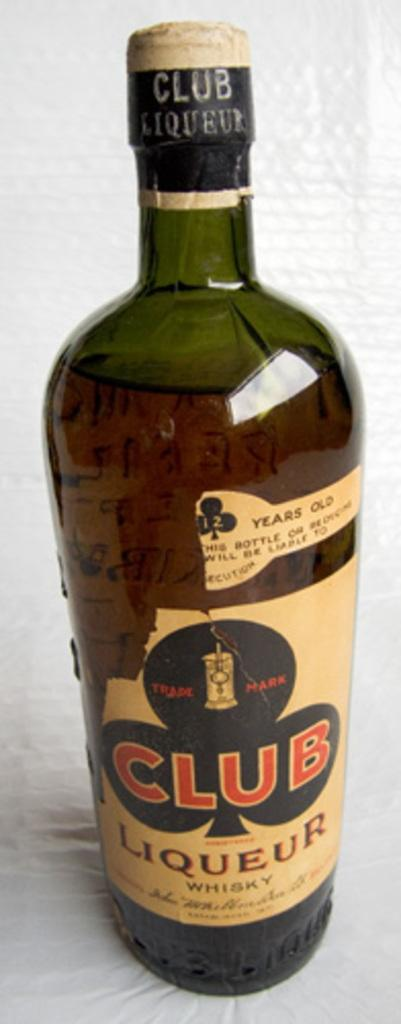Provide a one-sentence caption for the provided image. A club symbol decorates the label of a bottle of Club Liqueur. 